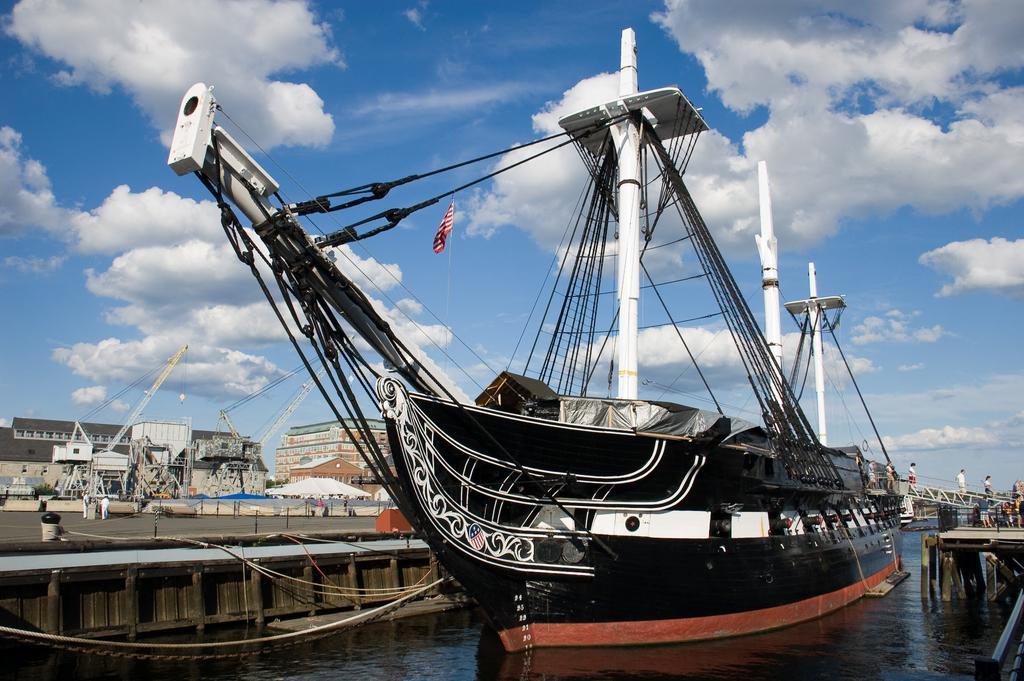In one or two sentences, can you explain what this image depicts? In the picture we can see the water with a ship in it which is black in color with some poles and wires to it and beside the ship we can see a path with some people are standing and in the background we can see the sky with clouds. 